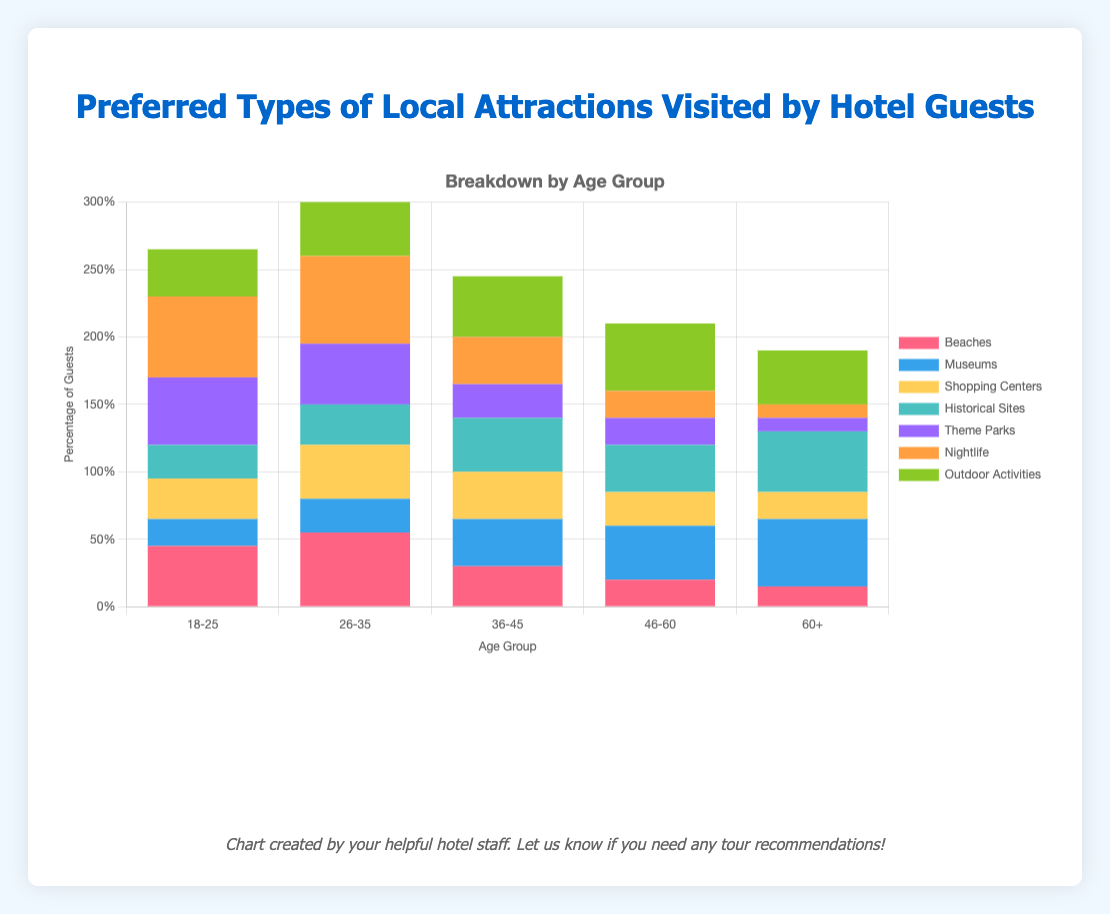What age group has the highest preference for beaches? By examining the heights of the bars representing beaches, we see that the 26-35 age group bar is the highest.
Answer: 26-35 Which age group prefers museums the most? By looking at the bars for museums, the tallest bar corresponds to the 60+ age group.
Answer: 60+ How many more people in the 18-25 age group prefer nightlife compared to historical sites? The preference for nightlife in the 18-25 age group is 60, and for historical sites is 25. The difference is 60 - 25 = 35.
Answer: 35 Is the preference for outdoor activities higher in the 46-60 age group compared to the 60+ age group? The bar for outdoor activities in the 46-60 age group is 50, while the 60+ age group has a bar height of 40. Since 50 > 40, the preference is higher in the 46-60 age group.
Answer: Yes Which two age groups have the least preference for theme parks? By looking at the theme park bars, the shortest bars belong to the 60+ and 46-60 age groups.
Answer: 60+ and 46-60 Considering shopping centers, how much more popular are they among 26-35 year-olds compared to 60+ year-olds? The preference for shopping centers is 40 for the 26-35 age group and 20 for the 60+ age group. The difference is 40 - 20 = 20.
Answer: 20 Which age group has the most varied preferences across different local attractions? The 18-25 age group shows the highest and low points across categories, indicating the most variance. For example, their preferences range from 20 (museums) to 60 (nightlife).
Answer: 18-25 What is the combined preference for theme parks and outdoor activities in the 36-45 age group? For the 36-45 age group, the preference for theme parks is 25 and for outdoor activities is 45. Combined, this is 25 + 45 = 70.
Answer: 70 Among the age groups, which one shows the smallest difference between their preference for museums and historical sites? The preferences for historical sites and museums across age groups can be compared: for 46-60, 40 (museums) - 35 (historical sites) = 5, which is the smallest difference compared to the other age groups.
Answer: 46-60 